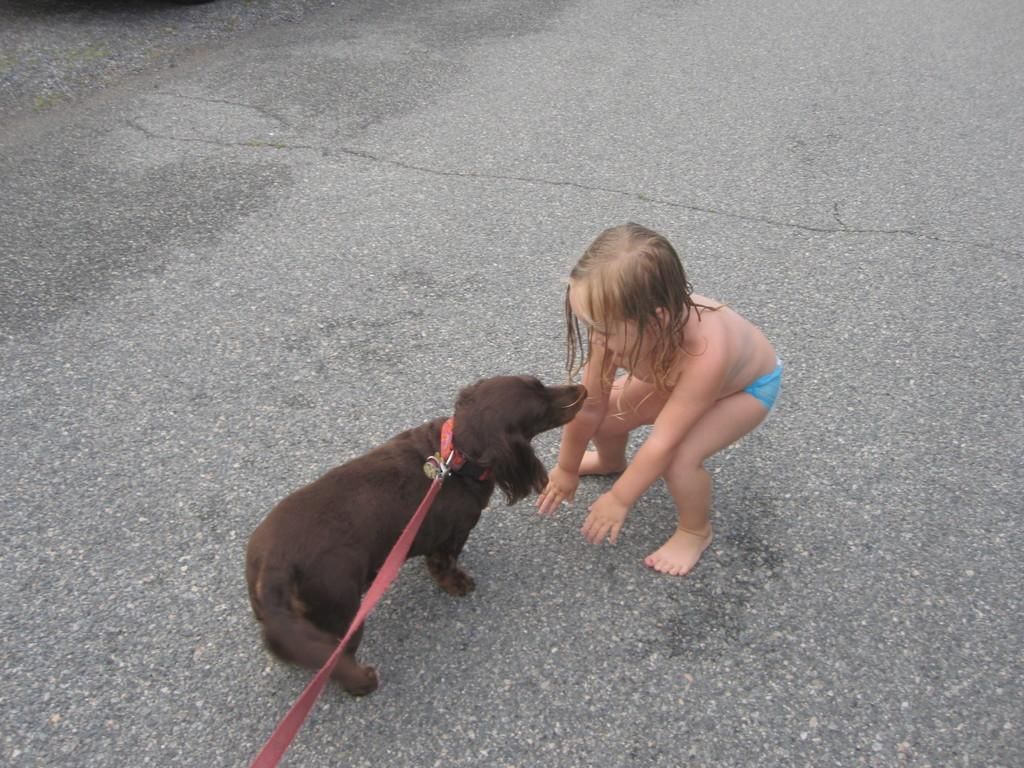What is the main subject of the image? There is a child in the image. Are there any other living beings present in the image? Yes, there is a dog in the image. What type of flowers can be seen growing around the child in the image? There are no flowers present in the image; it only features a child and a dog. What color is the apple that the child is holding in the image? There is no apple present in the image. 